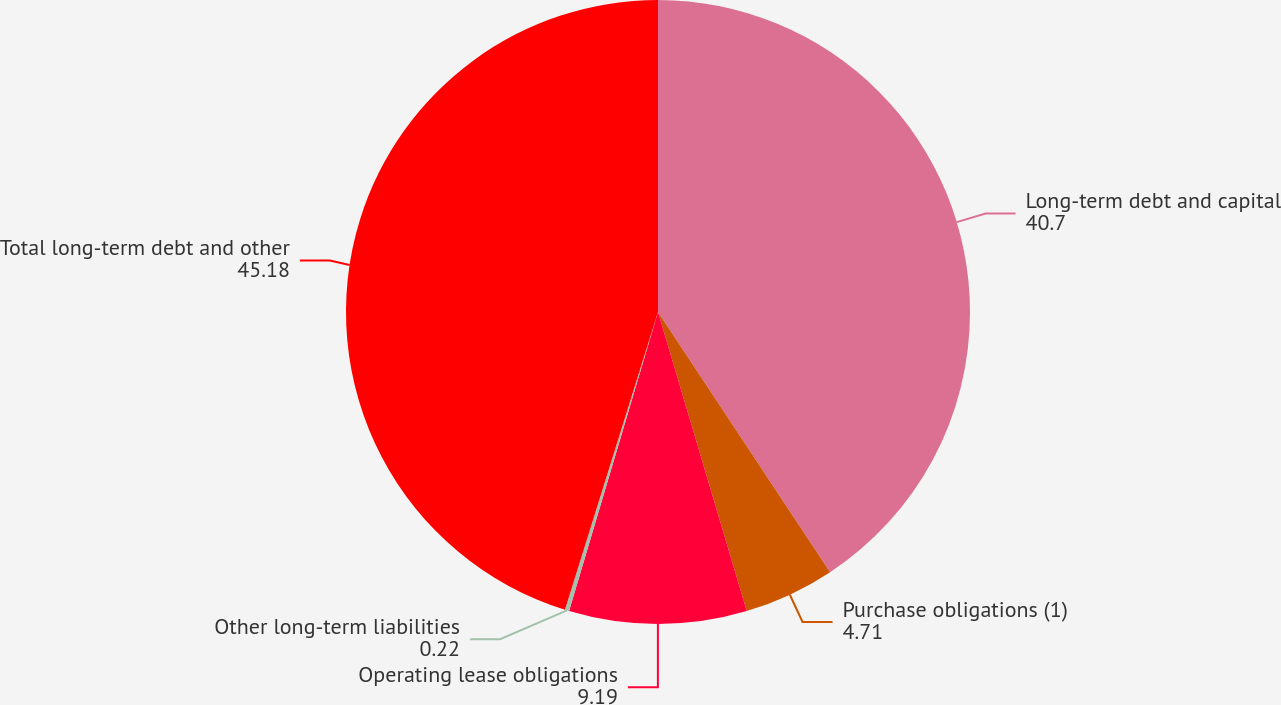<chart> <loc_0><loc_0><loc_500><loc_500><pie_chart><fcel>Long-term debt and capital<fcel>Purchase obligations (1)<fcel>Operating lease obligations<fcel>Other long-term liabilities<fcel>Total long-term debt and other<nl><fcel>40.7%<fcel>4.71%<fcel>9.19%<fcel>0.22%<fcel>45.18%<nl></chart> 